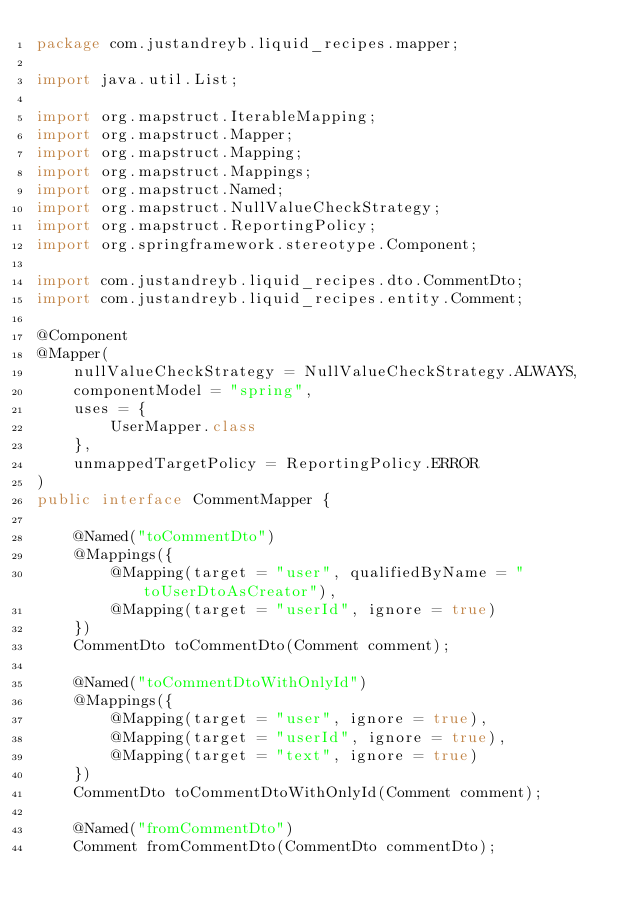<code> <loc_0><loc_0><loc_500><loc_500><_Java_>package com.justandreyb.liquid_recipes.mapper;

import java.util.List;

import org.mapstruct.IterableMapping;
import org.mapstruct.Mapper;
import org.mapstruct.Mapping;
import org.mapstruct.Mappings;
import org.mapstruct.Named;
import org.mapstruct.NullValueCheckStrategy;
import org.mapstruct.ReportingPolicy;
import org.springframework.stereotype.Component;

import com.justandreyb.liquid_recipes.dto.CommentDto;
import com.justandreyb.liquid_recipes.entity.Comment;

@Component
@Mapper(
    nullValueCheckStrategy = NullValueCheckStrategy.ALWAYS,
    componentModel = "spring",
    uses = {
        UserMapper.class
    },
    unmappedTargetPolicy = ReportingPolicy.ERROR
)
public interface CommentMapper {

    @Named("toCommentDto")
    @Mappings({
        @Mapping(target = "user", qualifiedByName = "toUserDtoAsCreator"),
        @Mapping(target = "userId", ignore = true)
    })
    CommentDto toCommentDto(Comment comment);

    @Named("toCommentDtoWithOnlyId")
    @Mappings({
        @Mapping(target = "user", ignore = true),
        @Mapping(target = "userId", ignore = true),
        @Mapping(target = "text", ignore = true)
    })
    CommentDto toCommentDtoWithOnlyId(Comment comment);

    @Named("fromCommentDto")
    Comment fromCommentDto(CommentDto commentDto);
</code> 